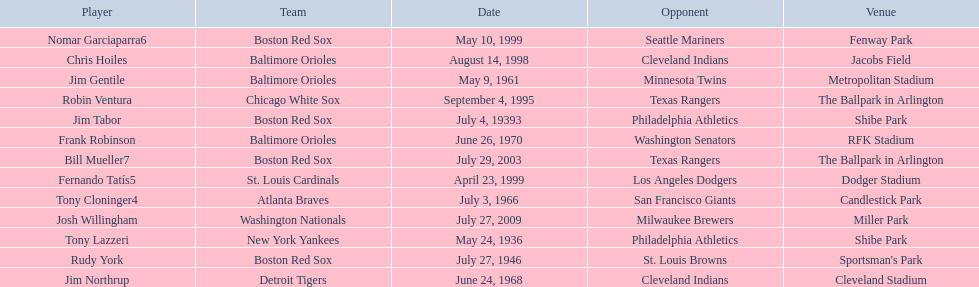What were the dates of each game? May 24, 1936, July 4, 19393, July 27, 1946, May 9, 1961, July 3, 1966, June 24, 1968, June 26, 1970, September 4, 1995, August 14, 1998, April 23, 1999, May 10, 1999, July 29, 2003, July 27, 2009. Who were all of the teams? New York Yankees, Boston Red Sox, Boston Red Sox, Baltimore Orioles, Atlanta Braves, Detroit Tigers, Baltimore Orioles, Chicago White Sox, Baltimore Orioles, St. Louis Cardinals, Boston Red Sox, Boston Red Sox, Washington Nationals. What about their opponents? Philadelphia Athletics, Philadelphia Athletics, St. Louis Browns, Minnesota Twins, San Francisco Giants, Cleveland Indians, Washington Senators, Texas Rangers, Cleveland Indians, Los Angeles Dodgers, Seattle Mariners, Texas Rangers, Milwaukee Brewers. And on which date did the detroit tigers play against the cleveland indians? June 24, 1968. 